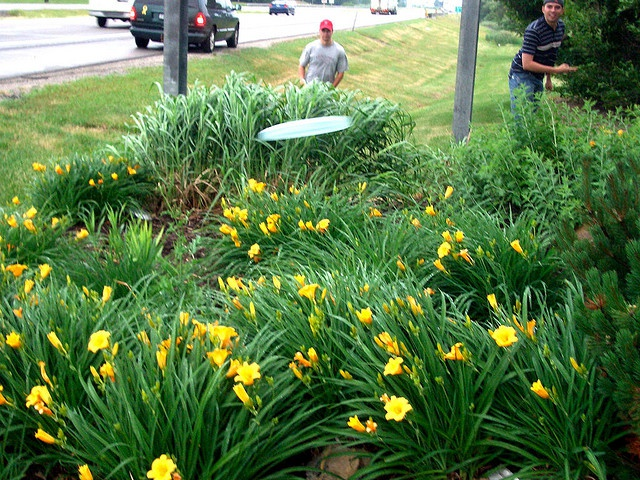Describe the objects in this image and their specific colors. I can see people in lightgreen, black, green, gray, and brown tones, car in lightgreen, black, gray, and white tones, people in lightgreen, lightgray, darkgray, and gray tones, frisbee in lightgreen, white, lightblue, teal, and turquoise tones, and car in lightgreen, white, black, darkgray, and gray tones in this image. 